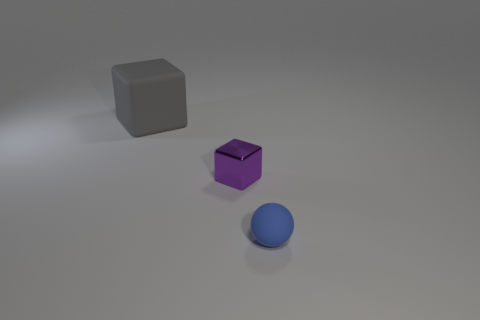Add 2 big red things. How many objects exist? 5 Subtract all cubes. How many objects are left? 1 Subtract 0 brown blocks. How many objects are left? 3 Subtract all rubber cylinders. Subtract all tiny rubber objects. How many objects are left? 2 Add 3 tiny metal cubes. How many tiny metal cubes are left? 4 Add 1 green spheres. How many green spheres exist? 1 